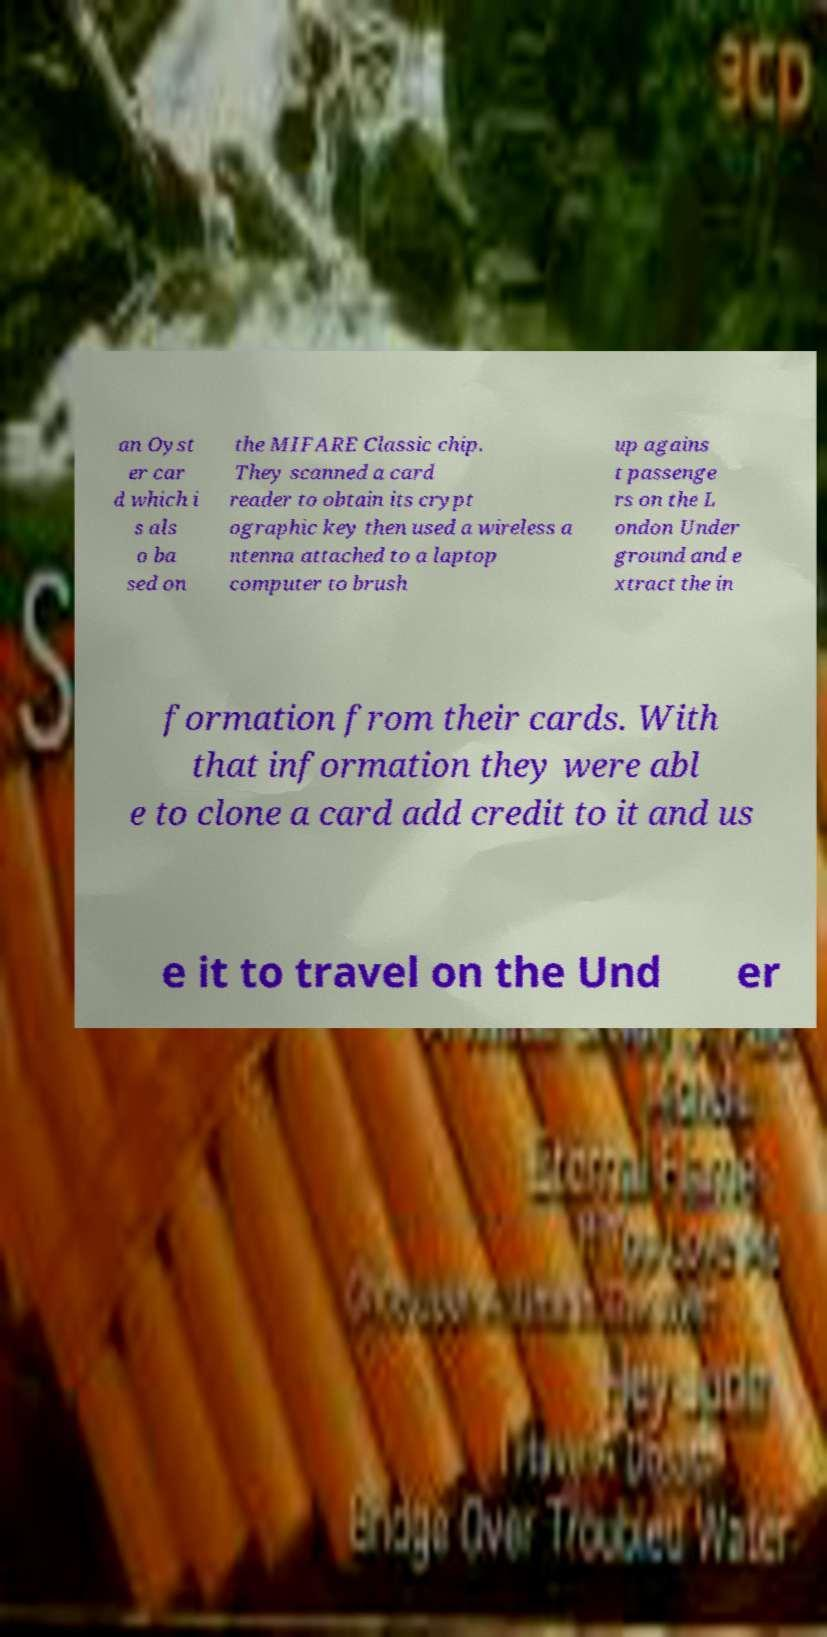Could you assist in decoding the text presented in this image and type it out clearly? an Oyst er car d which i s als o ba sed on the MIFARE Classic chip. They scanned a card reader to obtain its crypt ographic key then used a wireless a ntenna attached to a laptop computer to brush up agains t passenge rs on the L ondon Under ground and e xtract the in formation from their cards. With that information they were abl e to clone a card add credit to it and us e it to travel on the Und er 